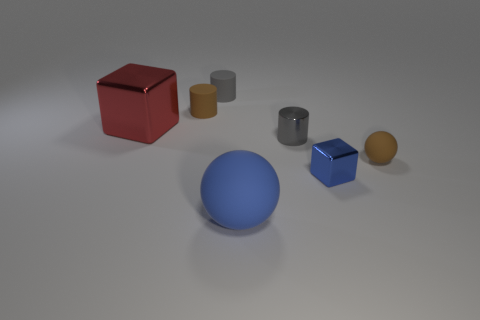There is a small block that is the same color as the large sphere; what material is it?
Your response must be concise. Metal. Are there any gray cylinders that are in front of the brown object that is on the left side of the matte sphere in front of the small blue block?
Your answer should be compact. Yes. What number of matte things are tiny brown balls or big red things?
Ensure brevity in your answer.  1. What number of other objects are there of the same shape as the gray shiny object?
Your answer should be compact. 2. Are there more big blocks than small red rubber spheres?
Your response must be concise. Yes. What is the size of the brown matte thing in front of the big object to the left of the brown rubber cylinder that is behind the big cube?
Make the answer very short. Small. There is a matte ball behind the big blue rubber object; what size is it?
Your answer should be very brief. Small. What number of things are small gray cylinders or big things in front of the big cube?
Your answer should be very brief. 3. What number of other things are there of the same size as the gray shiny object?
Ensure brevity in your answer.  4. There is a tiny thing that is the same shape as the big blue rubber thing; what is its material?
Your response must be concise. Rubber. 